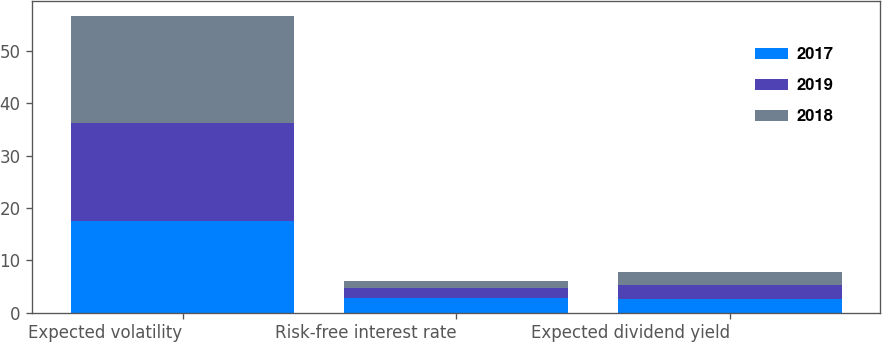<chart> <loc_0><loc_0><loc_500><loc_500><stacked_bar_chart><ecel><fcel>Expected volatility<fcel>Risk-free interest rate<fcel>Expected dividend yield<nl><fcel>2017<fcel>17.5<fcel>2.8<fcel>2.6<nl><fcel>2019<fcel>18.7<fcel>1.9<fcel>2.6<nl><fcel>2018<fcel>20.6<fcel>1.4<fcel>2.5<nl></chart> 